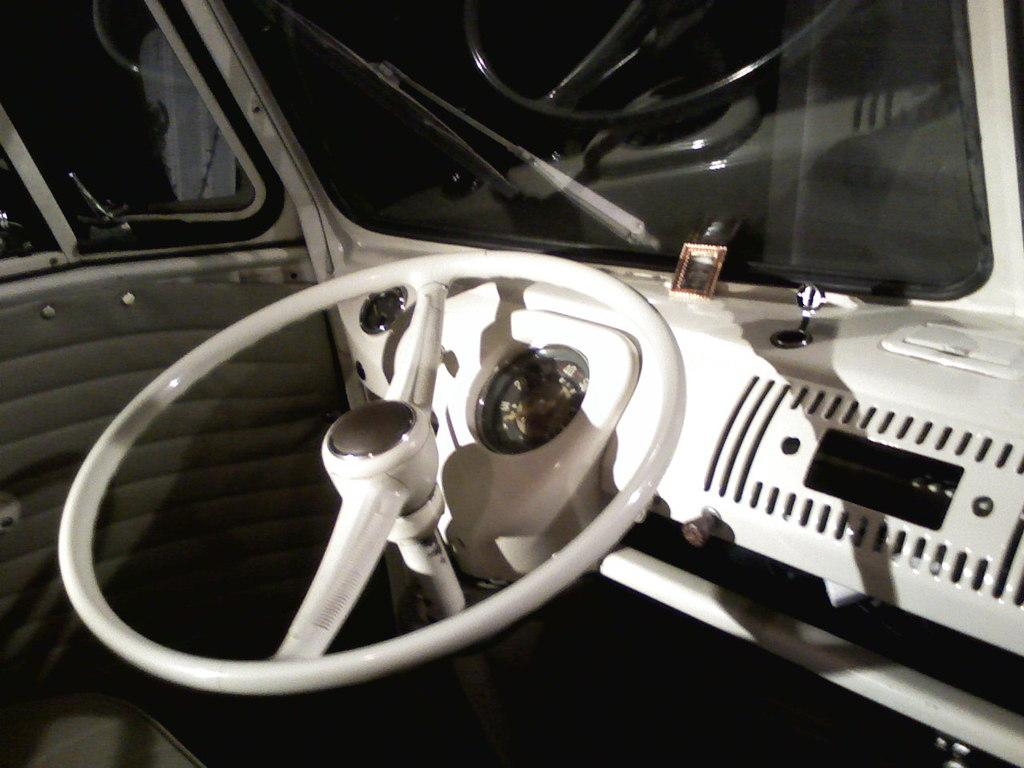What type of setting is depicted in the image? The image shows the interior of a motor vehicle. Is there a pet visible in the image? There is no mention of a pet in the facts provided, so we cannot determine if a pet is present in the image. 